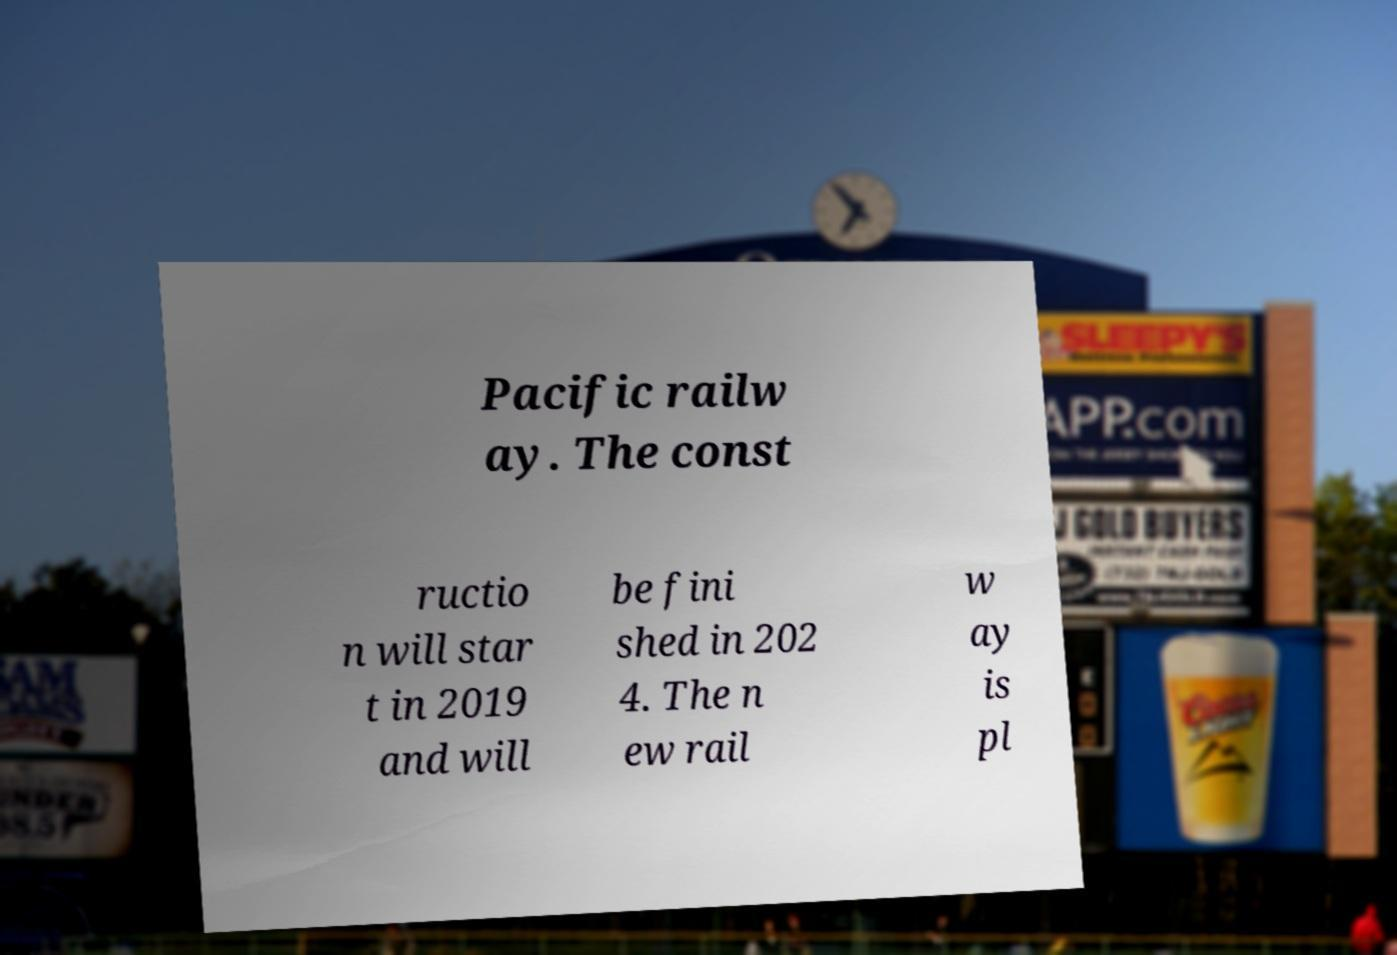Please read and relay the text visible in this image. What does it say? Pacific railw ay. The const ructio n will star t in 2019 and will be fini shed in 202 4. The n ew rail w ay is pl 